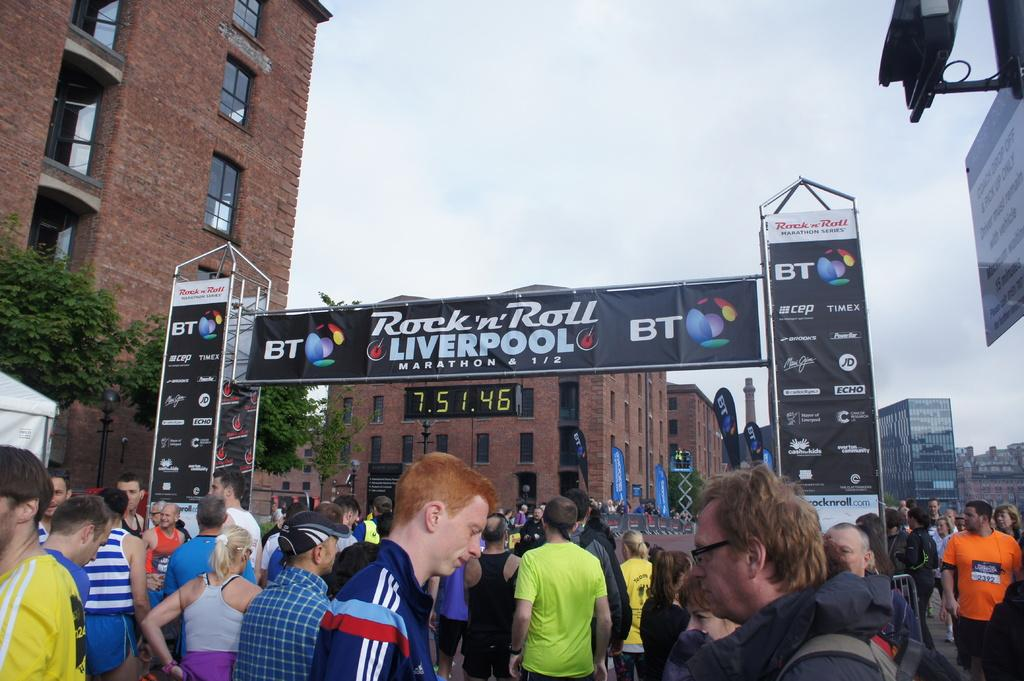<image>
Offer a succinct explanation of the picture presented. people waiting at rock n roll liverpool marathon starting gate 